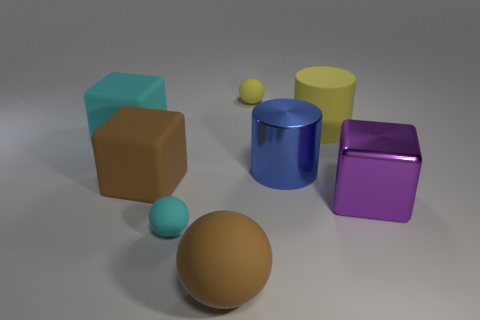Add 2 spheres. How many objects exist? 10 Subtract all blocks. How many objects are left? 5 Subtract all cyan matte spheres. Subtract all big purple objects. How many objects are left? 6 Add 8 large purple metallic things. How many large purple metallic things are left? 9 Add 5 small purple things. How many small purple things exist? 5 Subtract 0 gray cylinders. How many objects are left? 8 